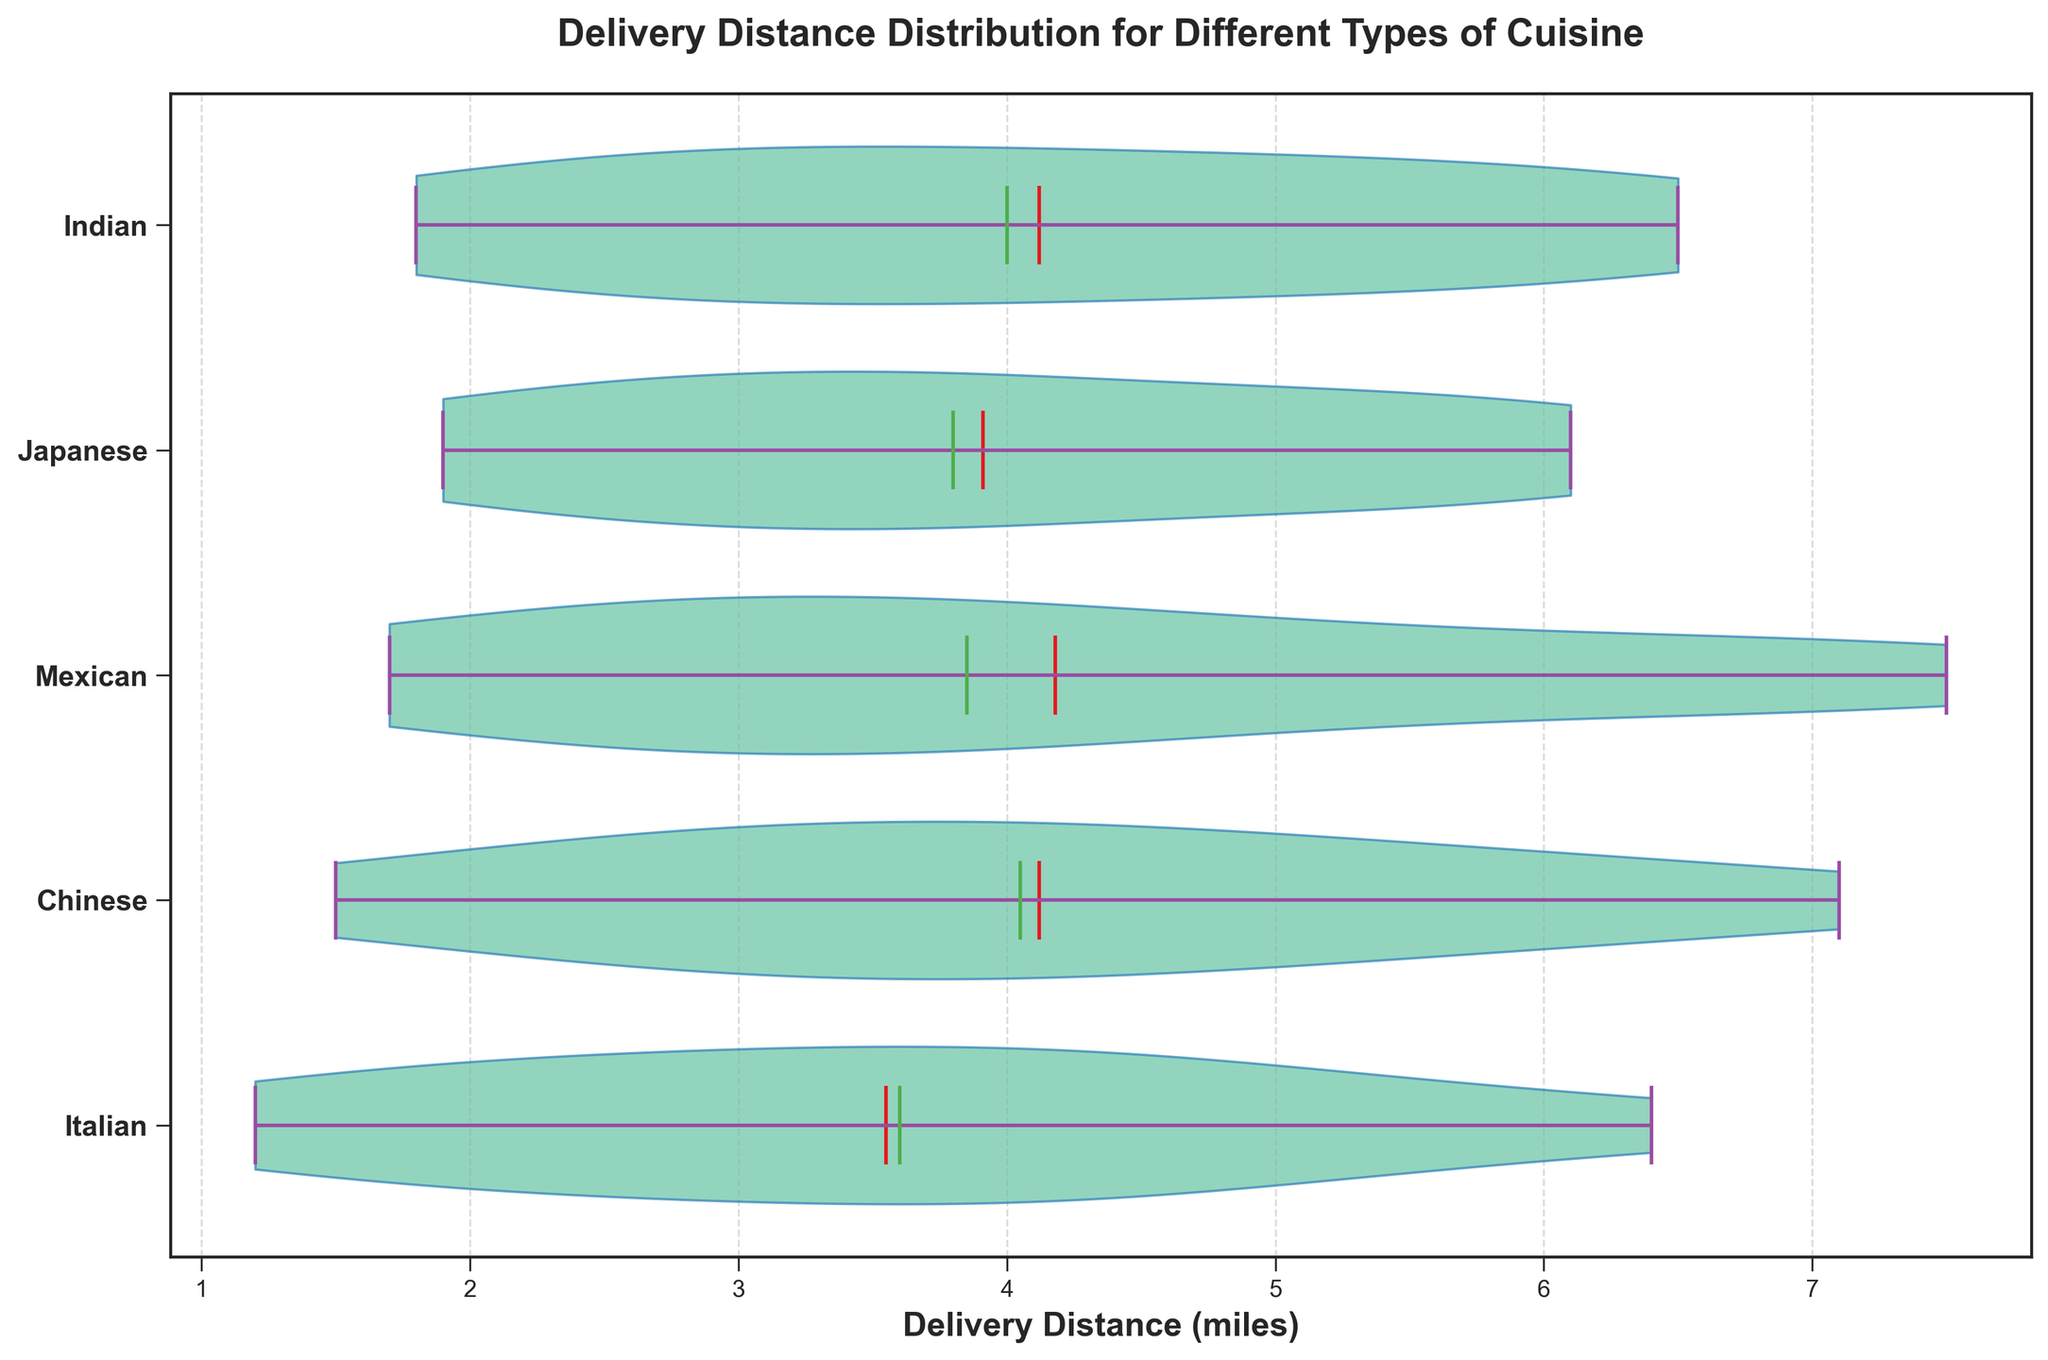Which cuisine has the largest average delivery distance? The average delivery distance can be visualized by the central white dot in each violin. Identify the cuisine with the white dot at the highest value on the x-axis.
Answer: Mexican What is the median delivery distance for Italian cuisine? The median delivery distance is shown by the horizontal green line within the violin plot for each cuisine. Locate the green line for Italian cuisine and note its position on the x-axis.
Answer: 3.5 Do any cuisines have delivery distances that exceed 7 miles? The maximum boundary of each violin plot shows the highest delivery distance for that cuisine. Check if any of these boundaries exceed the 7 miles mark on the x-axis.
Answer: Yes Which cuisine has the smallest delivery distance range? The delivery distance range is the span between the minimum and maximum delivery distances. Estimate the differences between the upper and lower range boundaries for each cuisine, and identify which one has the smallest span.
Answer: Italian How do the average delivery distances of Chinese and Japanese foods compare? Look at the central white dots of both Chinese and Japanese violin plots. Compare their positions on the x-axis to see which one is higher, indicating a larger average distance.
Answer: Chinese is greater Are the delivery distances of Indian cuisine more spread out compared to Italian cuisine? Assess the width of the violin plots for both Indian and Italian cuisines. A wider plot suggests more variability in the delivery distances. Compare the widths to see which is wider.
Answer: Yes Which cuisine has the shortest delivery distance median? The median delivery distances are highlighted by green lines within each violin plot. Identify the cuisine with the green line positioned at the lowest value on the x-axis.
Answer: Italian What is the approximate delivery distance range for Japanese cuisine? The range is the distance between the minimum and maximum values for the Japanese cuisine plot. Note the positions of the extreme boundaries and calculate the span between them.
Answer: ~1.9 to 6.1 Which cuisine has a median delivery distance closer to 4 miles? Inspect the position of the green horizontal lines (medians) and determine which plot shows a line closest to the 4-mile mark on the x-axis.
Answer: Japanese Is there a cuisine with very consistent delivery distances (low variance)? Consistent delivery distances will show a narrow and condensed violin plot. Identify the plot that appears the least spread out.
Answer: Italian 